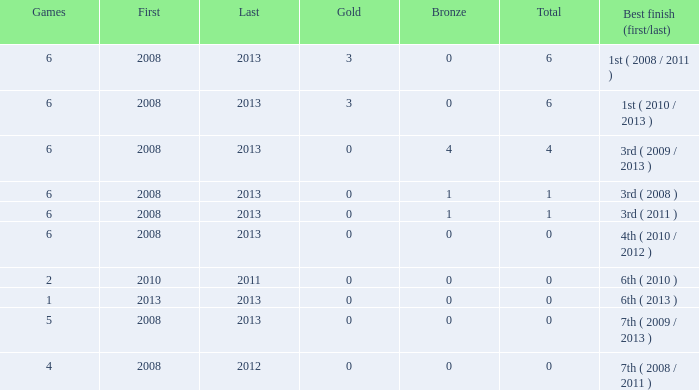I'm looking to parse the entire table for insights. Could you assist me with that? {'header': ['Games', 'First', 'Last', 'Gold', 'Bronze', 'Total', 'Best finish (first/last)'], 'rows': [['6', '2008', '2013', '3', '0', '6', '1st ( 2008 / 2011 )'], ['6', '2008', '2013', '3', '0', '6', '1st ( 2010 / 2013 )'], ['6', '2008', '2013', '0', '4', '4', '3rd ( 2009 / 2013 )'], ['6', '2008', '2013', '0', '1', '1', '3rd ( 2008 )'], ['6', '2008', '2013', '0', '1', '1', '3rd ( 2011 )'], ['6', '2008', '2013', '0', '0', '0', '4th ( 2010 / 2012 )'], ['2', '2010', '2011', '0', '0', '0', '6th ( 2010 )'], ['1', '2013', '2013', '0', '0', '0', '6th ( 2013 )'], ['5', '2008', '2013', '0', '0', '0', '7th ( 2009 / 2013 )'], ['4', '2008', '2012', '0', '0', '0', '7th ( 2008 / 2011 )']]} How many games are associated with over 0 golds and a first year before 2008? None. 